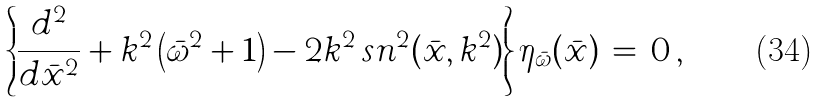Convert formula to latex. <formula><loc_0><loc_0><loc_500><loc_500>\left \{ \frac { d ^ { 2 } } { d \bar { x } ^ { 2 } } + k ^ { 2 } \left ( \bar { \omega } ^ { 2 } + 1 \right ) - 2 k ^ { 2 } \, s n ^ { 2 } ( \bar { x } , k ^ { 2 } ) \right \} \eta _ { \bar { \omega } } ( \bar { x } ) \, = \, 0 \, ,</formula> 